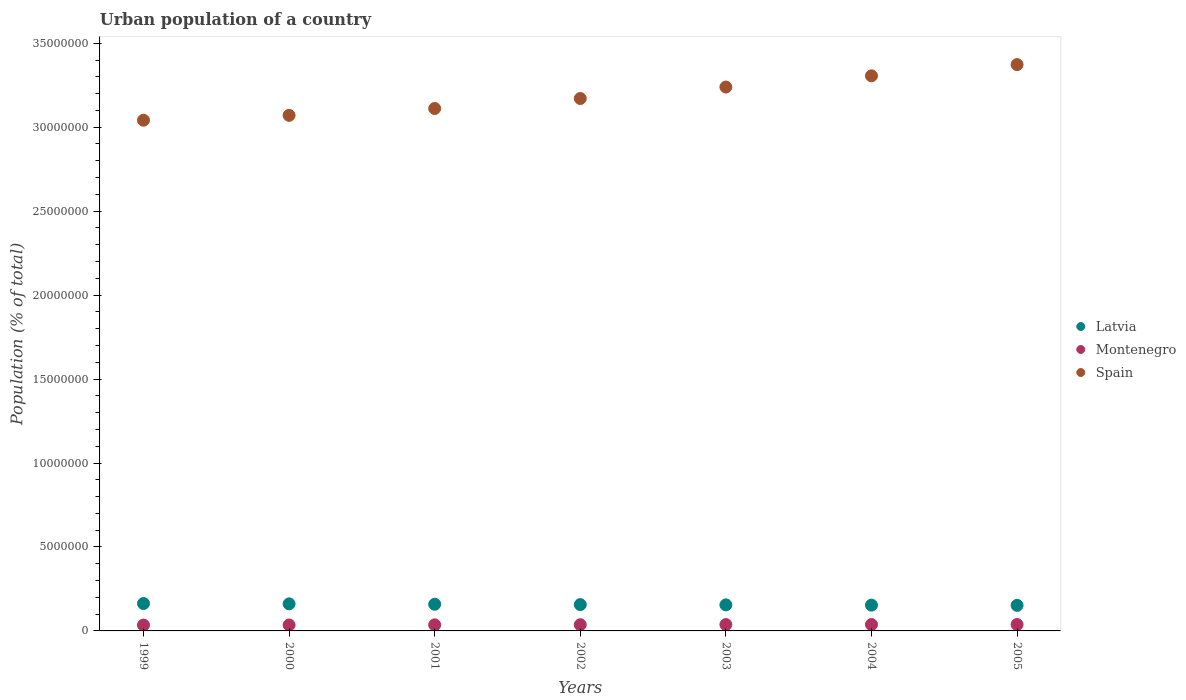How many different coloured dotlines are there?
Your answer should be very brief. 3. Is the number of dotlines equal to the number of legend labels?
Your answer should be compact. Yes. What is the urban population in Montenegro in 2002?
Offer a very short reply. 3.69e+05. Across all years, what is the maximum urban population in Latvia?
Ensure brevity in your answer.  1.63e+06. Across all years, what is the minimum urban population in Spain?
Ensure brevity in your answer.  3.04e+07. In which year was the urban population in Montenegro minimum?
Your answer should be compact. 1999. What is the total urban population in Montenegro in the graph?
Your answer should be compact. 2.57e+06. What is the difference between the urban population in Latvia in 2001 and that in 2003?
Offer a terse response. 3.69e+04. What is the difference between the urban population in Montenegro in 2004 and the urban population in Latvia in 2000?
Keep it short and to the point. -1.23e+06. What is the average urban population in Spain per year?
Provide a short and direct response. 3.19e+07. In the year 2002, what is the difference between the urban population in Latvia and urban population in Spain?
Provide a succinct answer. -3.01e+07. What is the ratio of the urban population in Montenegro in 2000 to that in 2003?
Keep it short and to the point. 0.94. Is the urban population in Montenegro in 1999 less than that in 2004?
Provide a succinct answer. Yes. What is the difference between the highest and the second highest urban population in Latvia?
Your answer should be compact. 1.93e+04. What is the difference between the highest and the lowest urban population in Montenegro?
Offer a terse response. 3.40e+04. Is the sum of the urban population in Latvia in 2002 and 2005 greater than the maximum urban population in Montenegro across all years?
Provide a short and direct response. Yes. Is it the case that in every year, the sum of the urban population in Montenegro and urban population in Spain  is greater than the urban population in Latvia?
Make the answer very short. Yes. How many years are there in the graph?
Give a very brief answer. 7. Are the values on the major ticks of Y-axis written in scientific E-notation?
Your answer should be compact. No. Does the graph contain grids?
Provide a short and direct response. No. Where does the legend appear in the graph?
Your answer should be compact. Center right. How many legend labels are there?
Keep it short and to the point. 3. How are the legend labels stacked?
Offer a very short reply. Vertical. What is the title of the graph?
Offer a terse response. Urban population of a country. Does "Curacao" appear as one of the legend labels in the graph?
Ensure brevity in your answer.  No. What is the label or title of the Y-axis?
Ensure brevity in your answer.  Population (% of total). What is the Population (% of total) in Latvia in 1999?
Offer a very short reply. 1.63e+06. What is the Population (% of total) of Montenegro in 1999?
Keep it short and to the point. 3.48e+05. What is the Population (% of total) in Spain in 1999?
Offer a terse response. 3.04e+07. What is the Population (% of total) of Latvia in 2000?
Keep it short and to the point. 1.61e+06. What is the Population (% of total) in Montenegro in 2000?
Give a very brief answer. 3.54e+05. What is the Population (% of total) in Spain in 2000?
Keep it short and to the point. 3.07e+07. What is the Population (% of total) of Latvia in 2001?
Your answer should be compact. 1.59e+06. What is the Population (% of total) in Montenegro in 2001?
Offer a very short reply. 3.62e+05. What is the Population (% of total) of Spain in 2001?
Ensure brevity in your answer.  3.11e+07. What is the Population (% of total) in Latvia in 2002?
Offer a very short reply. 1.57e+06. What is the Population (% of total) in Montenegro in 2002?
Your answer should be very brief. 3.69e+05. What is the Population (% of total) of Spain in 2002?
Keep it short and to the point. 3.17e+07. What is the Population (% of total) of Latvia in 2003?
Provide a succinct answer. 1.55e+06. What is the Population (% of total) in Montenegro in 2003?
Your answer should be very brief. 3.77e+05. What is the Population (% of total) of Spain in 2003?
Provide a short and direct response. 3.24e+07. What is the Population (% of total) in Latvia in 2004?
Provide a succinct answer. 1.54e+06. What is the Population (% of total) of Montenegro in 2004?
Your answer should be compact. 3.80e+05. What is the Population (% of total) in Spain in 2004?
Offer a terse response. 3.31e+07. What is the Population (% of total) of Latvia in 2005?
Keep it short and to the point. 1.52e+06. What is the Population (% of total) of Montenegro in 2005?
Ensure brevity in your answer.  3.82e+05. What is the Population (% of total) in Spain in 2005?
Keep it short and to the point. 3.37e+07. Across all years, what is the maximum Population (% of total) of Latvia?
Offer a very short reply. 1.63e+06. Across all years, what is the maximum Population (% of total) in Montenegro?
Ensure brevity in your answer.  3.82e+05. Across all years, what is the maximum Population (% of total) in Spain?
Offer a very short reply. 3.37e+07. Across all years, what is the minimum Population (% of total) in Latvia?
Ensure brevity in your answer.  1.52e+06. Across all years, what is the minimum Population (% of total) in Montenegro?
Your response must be concise. 3.48e+05. Across all years, what is the minimum Population (% of total) of Spain?
Give a very brief answer. 3.04e+07. What is the total Population (% of total) in Latvia in the graph?
Give a very brief answer. 1.10e+07. What is the total Population (% of total) of Montenegro in the graph?
Give a very brief answer. 2.57e+06. What is the total Population (% of total) of Spain in the graph?
Ensure brevity in your answer.  2.23e+08. What is the difference between the Population (% of total) in Latvia in 1999 and that in 2000?
Your answer should be compact. 1.93e+04. What is the difference between the Population (% of total) in Montenegro in 1999 and that in 2000?
Your response must be concise. -6110. What is the difference between the Population (% of total) in Spain in 1999 and that in 2000?
Provide a short and direct response. -2.89e+05. What is the difference between the Population (% of total) of Latvia in 1999 and that in 2001?
Your answer should be compact. 4.27e+04. What is the difference between the Population (% of total) of Montenegro in 1999 and that in 2001?
Your response must be concise. -1.37e+04. What is the difference between the Population (% of total) in Spain in 1999 and that in 2001?
Give a very brief answer. -6.98e+05. What is the difference between the Population (% of total) in Latvia in 1999 and that in 2002?
Provide a short and direct response. 6.33e+04. What is the difference between the Population (% of total) of Montenegro in 1999 and that in 2002?
Keep it short and to the point. -2.13e+04. What is the difference between the Population (% of total) of Spain in 1999 and that in 2002?
Offer a very short reply. -1.29e+06. What is the difference between the Population (% of total) in Latvia in 1999 and that in 2003?
Offer a very short reply. 7.96e+04. What is the difference between the Population (% of total) of Montenegro in 1999 and that in 2003?
Your answer should be compact. -2.89e+04. What is the difference between the Population (% of total) in Spain in 1999 and that in 2003?
Offer a terse response. -1.97e+06. What is the difference between the Population (% of total) of Latvia in 1999 and that in 2004?
Provide a succinct answer. 9.41e+04. What is the difference between the Population (% of total) of Montenegro in 1999 and that in 2004?
Give a very brief answer. -3.24e+04. What is the difference between the Population (% of total) in Spain in 1999 and that in 2004?
Provide a succinct answer. -2.64e+06. What is the difference between the Population (% of total) in Latvia in 1999 and that in 2005?
Keep it short and to the point. 1.08e+05. What is the difference between the Population (% of total) of Montenegro in 1999 and that in 2005?
Ensure brevity in your answer.  -3.40e+04. What is the difference between the Population (% of total) in Spain in 1999 and that in 2005?
Your response must be concise. -3.31e+06. What is the difference between the Population (% of total) in Latvia in 2000 and that in 2001?
Offer a terse response. 2.34e+04. What is the difference between the Population (% of total) in Montenegro in 2000 and that in 2001?
Make the answer very short. -7593. What is the difference between the Population (% of total) in Spain in 2000 and that in 2001?
Ensure brevity in your answer.  -4.09e+05. What is the difference between the Population (% of total) in Latvia in 2000 and that in 2002?
Provide a short and direct response. 4.41e+04. What is the difference between the Population (% of total) in Montenegro in 2000 and that in 2002?
Offer a terse response. -1.52e+04. What is the difference between the Population (% of total) in Spain in 2000 and that in 2002?
Offer a terse response. -1.00e+06. What is the difference between the Population (% of total) in Latvia in 2000 and that in 2003?
Offer a terse response. 6.03e+04. What is the difference between the Population (% of total) in Montenegro in 2000 and that in 2003?
Your answer should be very brief. -2.28e+04. What is the difference between the Population (% of total) of Spain in 2000 and that in 2003?
Ensure brevity in your answer.  -1.69e+06. What is the difference between the Population (% of total) of Latvia in 2000 and that in 2004?
Offer a very short reply. 7.49e+04. What is the difference between the Population (% of total) in Montenegro in 2000 and that in 2004?
Provide a short and direct response. -2.62e+04. What is the difference between the Population (% of total) of Spain in 2000 and that in 2004?
Keep it short and to the point. -2.35e+06. What is the difference between the Population (% of total) in Latvia in 2000 and that in 2005?
Provide a succinct answer. 8.91e+04. What is the difference between the Population (% of total) of Montenegro in 2000 and that in 2005?
Provide a short and direct response. -2.79e+04. What is the difference between the Population (% of total) of Spain in 2000 and that in 2005?
Your response must be concise. -3.02e+06. What is the difference between the Population (% of total) of Latvia in 2001 and that in 2002?
Your response must be concise. 2.07e+04. What is the difference between the Population (% of total) of Montenegro in 2001 and that in 2002?
Your answer should be very brief. -7606. What is the difference between the Population (% of total) of Spain in 2001 and that in 2002?
Offer a very short reply. -5.94e+05. What is the difference between the Population (% of total) of Latvia in 2001 and that in 2003?
Make the answer very short. 3.69e+04. What is the difference between the Population (% of total) in Montenegro in 2001 and that in 2003?
Keep it short and to the point. -1.52e+04. What is the difference between the Population (% of total) in Spain in 2001 and that in 2003?
Your answer should be very brief. -1.28e+06. What is the difference between the Population (% of total) in Latvia in 2001 and that in 2004?
Give a very brief answer. 5.14e+04. What is the difference between the Population (% of total) in Montenegro in 2001 and that in 2004?
Provide a succinct answer. -1.86e+04. What is the difference between the Population (% of total) in Spain in 2001 and that in 2004?
Keep it short and to the point. -1.94e+06. What is the difference between the Population (% of total) in Latvia in 2001 and that in 2005?
Give a very brief answer. 6.57e+04. What is the difference between the Population (% of total) of Montenegro in 2001 and that in 2005?
Offer a very short reply. -2.03e+04. What is the difference between the Population (% of total) in Spain in 2001 and that in 2005?
Offer a terse response. -2.61e+06. What is the difference between the Population (% of total) in Latvia in 2002 and that in 2003?
Offer a terse response. 1.62e+04. What is the difference between the Population (% of total) of Montenegro in 2002 and that in 2003?
Your answer should be compact. -7600. What is the difference between the Population (% of total) in Spain in 2002 and that in 2003?
Your response must be concise. -6.82e+05. What is the difference between the Population (% of total) in Latvia in 2002 and that in 2004?
Your answer should be very brief. 3.08e+04. What is the difference between the Population (% of total) of Montenegro in 2002 and that in 2004?
Your answer should be compact. -1.10e+04. What is the difference between the Population (% of total) in Spain in 2002 and that in 2004?
Keep it short and to the point. -1.35e+06. What is the difference between the Population (% of total) of Latvia in 2002 and that in 2005?
Ensure brevity in your answer.  4.51e+04. What is the difference between the Population (% of total) of Montenegro in 2002 and that in 2005?
Provide a short and direct response. -1.27e+04. What is the difference between the Population (% of total) of Spain in 2002 and that in 2005?
Keep it short and to the point. -2.02e+06. What is the difference between the Population (% of total) in Latvia in 2003 and that in 2004?
Offer a terse response. 1.46e+04. What is the difference between the Population (% of total) of Montenegro in 2003 and that in 2004?
Your answer should be very brief. -3441. What is the difference between the Population (% of total) of Spain in 2003 and that in 2004?
Your answer should be very brief. -6.68e+05. What is the difference between the Population (% of total) of Latvia in 2003 and that in 2005?
Provide a succinct answer. 2.88e+04. What is the difference between the Population (% of total) of Montenegro in 2003 and that in 2005?
Your response must be concise. -5109. What is the difference between the Population (% of total) of Spain in 2003 and that in 2005?
Your answer should be compact. -1.34e+06. What is the difference between the Population (% of total) of Latvia in 2004 and that in 2005?
Your answer should be compact. 1.43e+04. What is the difference between the Population (% of total) in Montenegro in 2004 and that in 2005?
Your response must be concise. -1668. What is the difference between the Population (% of total) in Spain in 2004 and that in 2005?
Offer a terse response. -6.68e+05. What is the difference between the Population (% of total) in Latvia in 1999 and the Population (% of total) in Montenegro in 2000?
Your response must be concise. 1.28e+06. What is the difference between the Population (% of total) in Latvia in 1999 and the Population (% of total) in Spain in 2000?
Offer a very short reply. -2.91e+07. What is the difference between the Population (% of total) of Montenegro in 1999 and the Population (% of total) of Spain in 2000?
Keep it short and to the point. -3.04e+07. What is the difference between the Population (% of total) in Latvia in 1999 and the Population (% of total) in Montenegro in 2001?
Offer a terse response. 1.27e+06. What is the difference between the Population (% of total) in Latvia in 1999 and the Population (% of total) in Spain in 2001?
Your answer should be very brief. -2.95e+07. What is the difference between the Population (% of total) in Montenegro in 1999 and the Population (% of total) in Spain in 2001?
Offer a very short reply. -3.08e+07. What is the difference between the Population (% of total) in Latvia in 1999 and the Population (% of total) in Montenegro in 2002?
Offer a terse response. 1.26e+06. What is the difference between the Population (% of total) in Latvia in 1999 and the Population (% of total) in Spain in 2002?
Make the answer very short. -3.01e+07. What is the difference between the Population (% of total) in Montenegro in 1999 and the Population (% of total) in Spain in 2002?
Offer a terse response. -3.14e+07. What is the difference between the Population (% of total) in Latvia in 1999 and the Population (% of total) in Montenegro in 2003?
Provide a succinct answer. 1.25e+06. What is the difference between the Population (% of total) of Latvia in 1999 and the Population (% of total) of Spain in 2003?
Ensure brevity in your answer.  -3.08e+07. What is the difference between the Population (% of total) in Montenegro in 1999 and the Population (% of total) in Spain in 2003?
Your answer should be compact. -3.20e+07. What is the difference between the Population (% of total) in Latvia in 1999 and the Population (% of total) in Montenegro in 2004?
Your answer should be very brief. 1.25e+06. What is the difference between the Population (% of total) in Latvia in 1999 and the Population (% of total) in Spain in 2004?
Your answer should be very brief. -3.14e+07. What is the difference between the Population (% of total) in Montenegro in 1999 and the Population (% of total) in Spain in 2004?
Keep it short and to the point. -3.27e+07. What is the difference between the Population (% of total) in Latvia in 1999 and the Population (% of total) in Montenegro in 2005?
Give a very brief answer. 1.25e+06. What is the difference between the Population (% of total) of Latvia in 1999 and the Population (% of total) of Spain in 2005?
Provide a succinct answer. -3.21e+07. What is the difference between the Population (% of total) in Montenegro in 1999 and the Population (% of total) in Spain in 2005?
Your response must be concise. -3.34e+07. What is the difference between the Population (% of total) in Latvia in 2000 and the Population (% of total) in Montenegro in 2001?
Your answer should be compact. 1.25e+06. What is the difference between the Population (% of total) in Latvia in 2000 and the Population (% of total) in Spain in 2001?
Give a very brief answer. -2.95e+07. What is the difference between the Population (% of total) in Montenegro in 2000 and the Population (% of total) in Spain in 2001?
Your answer should be compact. -3.08e+07. What is the difference between the Population (% of total) in Latvia in 2000 and the Population (% of total) in Montenegro in 2002?
Offer a very short reply. 1.24e+06. What is the difference between the Population (% of total) in Latvia in 2000 and the Population (% of total) in Spain in 2002?
Make the answer very short. -3.01e+07. What is the difference between the Population (% of total) of Montenegro in 2000 and the Population (% of total) of Spain in 2002?
Your answer should be compact. -3.14e+07. What is the difference between the Population (% of total) of Latvia in 2000 and the Population (% of total) of Montenegro in 2003?
Offer a terse response. 1.23e+06. What is the difference between the Population (% of total) of Latvia in 2000 and the Population (% of total) of Spain in 2003?
Provide a short and direct response. -3.08e+07. What is the difference between the Population (% of total) in Montenegro in 2000 and the Population (% of total) in Spain in 2003?
Your answer should be very brief. -3.20e+07. What is the difference between the Population (% of total) of Latvia in 2000 and the Population (% of total) of Montenegro in 2004?
Keep it short and to the point. 1.23e+06. What is the difference between the Population (% of total) of Latvia in 2000 and the Population (% of total) of Spain in 2004?
Provide a short and direct response. -3.14e+07. What is the difference between the Population (% of total) of Montenegro in 2000 and the Population (% of total) of Spain in 2004?
Your answer should be very brief. -3.27e+07. What is the difference between the Population (% of total) in Latvia in 2000 and the Population (% of total) in Montenegro in 2005?
Your answer should be very brief. 1.23e+06. What is the difference between the Population (% of total) of Latvia in 2000 and the Population (% of total) of Spain in 2005?
Provide a short and direct response. -3.21e+07. What is the difference between the Population (% of total) of Montenegro in 2000 and the Population (% of total) of Spain in 2005?
Offer a very short reply. -3.34e+07. What is the difference between the Population (% of total) of Latvia in 2001 and the Population (% of total) of Montenegro in 2002?
Your answer should be very brief. 1.22e+06. What is the difference between the Population (% of total) of Latvia in 2001 and the Population (% of total) of Spain in 2002?
Ensure brevity in your answer.  -3.01e+07. What is the difference between the Population (% of total) of Montenegro in 2001 and the Population (% of total) of Spain in 2002?
Ensure brevity in your answer.  -3.13e+07. What is the difference between the Population (% of total) of Latvia in 2001 and the Population (% of total) of Montenegro in 2003?
Provide a succinct answer. 1.21e+06. What is the difference between the Population (% of total) of Latvia in 2001 and the Population (% of total) of Spain in 2003?
Keep it short and to the point. -3.08e+07. What is the difference between the Population (% of total) of Montenegro in 2001 and the Population (% of total) of Spain in 2003?
Provide a short and direct response. -3.20e+07. What is the difference between the Population (% of total) of Latvia in 2001 and the Population (% of total) of Montenegro in 2004?
Your response must be concise. 1.21e+06. What is the difference between the Population (% of total) in Latvia in 2001 and the Population (% of total) in Spain in 2004?
Keep it short and to the point. -3.15e+07. What is the difference between the Population (% of total) in Montenegro in 2001 and the Population (% of total) in Spain in 2004?
Give a very brief answer. -3.27e+07. What is the difference between the Population (% of total) in Latvia in 2001 and the Population (% of total) in Montenegro in 2005?
Your answer should be very brief. 1.21e+06. What is the difference between the Population (% of total) in Latvia in 2001 and the Population (% of total) in Spain in 2005?
Offer a terse response. -3.21e+07. What is the difference between the Population (% of total) of Montenegro in 2001 and the Population (% of total) of Spain in 2005?
Keep it short and to the point. -3.34e+07. What is the difference between the Population (% of total) of Latvia in 2002 and the Population (% of total) of Montenegro in 2003?
Offer a very short reply. 1.19e+06. What is the difference between the Population (% of total) of Latvia in 2002 and the Population (% of total) of Spain in 2003?
Your answer should be compact. -3.08e+07. What is the difference between the Population (% of total) in Montenegro in 2002 and the Population (% of total) in Spain in 2003?
Offer a very short reply. -3.20e+07. What is the difference between the Population (% of total) in Latvia in 2002 and the Population (% of total) in Montenegro in 2004?
Your answer should be very brief. 1.19e+06. What is the difference between the Population (% of total) in Latvia in 2002 and the Population (% of total) in Spain in 2004?
Ensure brevity in your answer.  -3.15e+07. What is the difference between the Population (% of total) of Montenegro in 2002 and the Population (% of total) of Spain in 2004?
Keep it short and to the point. -3.27e+07. What is the difference between the Population (% of total) of Latvia in 2002 and the Population (% of total) of Montenegro in 2005?
Keep it short and to the point. 1.19e+06. What is the difference between the Population (% of total) of Latvia in 2002 and the Population (% of total) of Spain in 2005?
Make the answer very short. -3.22e+07. What is the difference between the Population (% of total) in Montenegro in 2002 and the Population (% of total) in Spain in 2005?
Provide a short and direct response. -3.34e+07. What is the difference between the Population (% of total) of Latvia in 2003 and the Population (% of total) of Montenegro in 2004?
Provide a short and direct response. 1.17e+06. What is the difference between the Population (% of total) of Latvia in 2003 and the Population (% of total) of Spain in 2004?
Offer a very short reply. -3.15e+07. What is the difference between the Population (% of total) of Montenegro in 2003 and the Population (% of total) of Spain in 2004?
Keep it short and to the point. -3.27e+07. What is the difference between the Population (% of total) in Latvia in 2003 and the Population (% of total) in Montenegro in 2005?
Your response must be concise. 1.17e+06. What is the difference between the Population (% of total) in Latvia in 2003 and the Population (% of total) in Spain in 2005?
Your answer should be very brief. -3.22e+07. What is the difference between the Population (% of total) of Montenegro in 2003 and the Population (% of total) of Spain in 2005?
Ensure brevity in your answer.  -3.34e+07. What is the difference between the Population (% of total) in Latvia in 2004 and the Population (% of total) in Montenegro in 2005?
Ensure brevity in your answer.  1.15e+06. What is the difference between the Population (% of total) of Latvia in 2004 and the Population (% of total) of Spain in 2005?
Offer a terse response. -3.22e+07. What is the difference between the Population (% of total) of Montenegro in 2004 and the Population (% of total) of Spain in 2005?
Provide a succinct answer. -3.33e+07. What is the average Population (% of total) in Latvia per year?
Give a very brief answer. 1.57e+06. What is the average Population (% of total) in Montenegro per year?
Provide a short and direct response. 3.68e+05. What is the average Population (% of total) in Spain per year?
Your answer should be compact. 3.19e+07. In the year 1999, what is the difference between the Population (% of total) in Latvia and Population (% of total) in Montenegro?
Offer a very short reply. 1.28e+06. In the year 1999, what is the difference between the Population (% of total) of Latvia and Population (% of total) of Spain?
Your response must be concise. -2.88e+07. In the year 1999, what is the difference between the Population (% of total) in Montenegro and Population (% of total) in Spain?
Offer a very short reply. -3.01e+07. In the year 2000, what is the difference between the Population (% of total) of Latvia and Population (% of total) of Montenegro?
Provide a succinct answer. 1.26e+06. In the year 2000, what is the difference between the Population (% of total) of Latvia and Population (% of total) of Spain?
Ensure brevity in your answer.  -2.91e+07. In the year 2000, what is the difference between the Population (% of total) of Montenegro and Population (% of total) of Spain?
Make the answer very short. -3.04e+07. In the year 2001, what is the difference between the Population (% of total) of Latvia and Population (% of total) of Montenegro?
Keep it short and to the point. 1.23e+06. In the year 2001, what is the difference between the Population (% of total) in Latvia and Population (% of total) in Spain?
Offer a terse response. -2.95e+07. In the year 2001, what is the difference between the Population (% of total) of Montenegro and Population (% of total) of Spain?
Offer a terse response. -3.08e+07. In the year 2002, what is the difference between the Population (% of total) in Latvia and Population (% of total) in Montenegro?
Your response must be concise. 1.20e+06. In the year 2002, what is the difference between the Population (% of total) in Latvia and Population (% of total) in Spain?
Keep it short and to the point. -3.01e+07. In the year 2002, what is the difference between the Population (% of total) of Montenegro and Population (% of total) of Spain?
Keep it short and to the point. -3.13e+07. In the year 2003, what is the difference between the Population (% of total) in Latvia and Population (% of total) in Montenegro?
Your response must be concise. 1.17e+06. In the year 2003, what is the difference between the Population (% of total) of Latvia and Population (% of total) of Spain?
Keep it short and to the point. -3.08e+07. In the year 2003, what is the difference between the Population (% of total) in Montenegro and Population (% of total) in Spain?
Your response must be concise. -3.20e+07. In the year 2004, what is the difference between the Population (% of total) in Latvia and Population (% of total) in Montenegro?
Keep it short and to the point. 1.16e+06. In the year 2004, what is the difference between the Population (% of total) of Latvia and Population (% of total) of Spain?
Provide a succinct answer. -3.15e+07. In the year 2004, what is the difference between the Population (% of total) in Montenegro and Population (% of total) in Spain?
Your answer should be compact. -3.27e+07. In the year 2005, what is the difference between the Population (% of total) in Latvia and Population (% of total) in Montenegro?
Offer a terse response. 1.14e+06. In the year 2005, what is the difference between the Population (% of total) in Latvia and Population (% of total) in Spain?
Give a very brief answer. -3.22e+07. In the year 2005, what is the difference between the Population (% of total) in Montenegro and Population (% of total) in Spain?
Make the answer very short. -3.33e+07. What is the ratio of the Population (% of total) of Montenegro in 1999 to that in 2000?
Provide a succinct answer. 0.98. What is the ratio of the Population (% of total) of Spain in 1999 to that in 2000?
Your response must be concise. 0.99. What is the ratio of the Population (% of total) of Latvia in 1999 to that in 2001?
Ensure brevity in your answer.  1.03. What is the ratio of the Population (% of total) of Montenegro in 1999 to that in 2001?
Your response must be concise. 0.96. What is the ratio of the Population (% of total) of Spain in 1999 to that in 2001?
Offer a terse response. 0.98. What is the ratio of the Population (% of total) in Latvia in 1999 to that in 2002?
Ensure brevity in your answer.  1.04. What is the ratio of the Population (% of total) of Montenegro in 1999 to that in 2002?
Provide a short and direct response. 0.94. What is the ratio of the Population (% of total) in Spain in 1999 to that in 2002?
Your answer should be very brief. 0.96. What is the ratio of the Population (% of total) of Latvia in 1999 to that in 2003?
Your answer should be compact. 1.05. What is the ratio of the Population (% of total) of Montenegro in 1999 to that in 2003?
Provide a succinct answer. 0.92. What is the ratio of the Population (% of total) in Spain in 1999 to that in 2003?
Ensure brevity in your answer.  0.94. What is the ratio of the Population (% of total) of Latvia in 1999 to that in 2004?
Offer a very short reply. 1.06. What is the ratio of the Population (% of total) of Montenegro in 1999 to that in 2004?
Make the answer very short. 0.92. What is the ratio of the Population (% of total) of Spain in 1999 to that in 2004?
Offer a very short reply. 0.92. What is the ratio of the Population (% of total) of Latvia in 1999 to that in 2005?
Make the answer very short. 1.07. What is the ratio of the Population (% of total) of Montenegro in 1999 to that in 2005?
Make the answer very short. 0.91. What is the ratio of the Population (% of total) of Spain in 1999 to that in 2005?
Offer a very short reply. 0.9. What is the ratio of the Population (% of total) in Latvia in 2000 to that in 2001?
Your answer should be compact. 1.01. What is the ratio of the Population (% of total) of Montenegro in 2000 to that in 2001?
Your response must be concise. 0.98. What is the ratio of the Population (% of total) of Spain in 2000 to that in 2001?
Offer a very short reply. 0.99. What is the ratio of the Population (% of total) in Latvia in 2000 to that in 2002?
Offer a very short reply. 1.03. What is the ratio of the Population (% of total) in Montenegro in 2000 to that in 2002?
Provide a succinct answer. 0.96. What is the ratio of the Population (% of total) of Spain in 2000 to that in 2002?
Give a very brief answer. 0.97. What is the ratio of the Population (% of total) in Latvia in 2000 to that in 2003?
Your response must be concise. 1.04. What is the ratio of the Population (% of total) in Montenegro in 2000 to that in 2003?
Keep it short and to the point. 0.94. What is the ratio of the Population (% of total) in Spain in 2000 to that in 2003?
Your answer should be compact. 0.95. What is the ratio of the Population (% of total) in Latvia in 2000 to that in 2004?
Offer a terse response. 1.05. What is the ratio of the Population (% of total) of Montenegro in 2000 to that in 2004?
Offer a terse response. 0.93. What is the ratio of the Population (% of total) in Spain in 2000 to that in 2004?
Offer a very short reply. 0.93. What is the ratio of the Population (% of total) of Latvia in 2000 to that in 2005?
Ensure brevity in your answer.  1.06. What is the ratio of the Population (% of total) in Montenegro in 2000 to that in 2005?
Provide a short and direct response. 0.93. What is the ratio of the Population (% of total) in Spain in 2000 to that in 2005?
Make the answer very short. 0.91. What is the ratio of the Population (% of total) of Latvia in 2001 to that in 2002?
Provide a short and direct response. 1.01. What is the ratio of the Population (% of total) in Montenegro in 2001 to that in 2002?
Offer a terse response. 0.98. What is the ratio of the Population (% of total) in Spain in 2001 to that in 2002?
Your response must be concise. 0.98. What is the ratio of the Population (% of total) of Latvia in 2001 to that in 2003?
Ensure brevity in your answer.  1.02. What is the ratio of the Population (% of total) in Montenegro in 2001 to that in 2003?
Offer a terse response. 0.96. What is the ratio of the Population (% of total) in Spain in 2001 to that in 2003?
Your answer should be compact. 0.96. What is the ratio of the Population (% of total) in Latvia in 2001 to that in 2004?
Give a very brief answer. 1.03. What is the ratio of the Population (% of total) of Montenegro in 2001 to that in 2004?
Offer a terse response. 0.95. What is the ratio of the Population (% of total) of Spain in 2001 to that in 2004?
Offer a terse response. 0.94. What is the ratio of the Population (% of total) of Latvia in 2001 to that in 2005?
Your response must be concise. 1.04. What is the ratio of the Population (% of total) in Montenegro in 2001 to that in 2005?
Provide a succinct answer. 0.95. What is the ratio of the Population (% of total) of Spain in 2001 to that in 2005?
Offer a terse response. 0.92. What is the ratio of the Population (% of total) in Latvia in 2002 to that in 2003?
Provide a short and direct response. 1.01. What is the ratio of the Population (% of total) of Montenegro in 2002 to that in 2003?
Ensure brevity in your answer.  0.98. What is the ratio of the Population (% of total) in Spain in 2002 to that in 2003?
Keep it short and to the point. 0.98. What is the ratio of the Population (% of total) in Latvia in 2002 to that in 2004?
Your response must be concise. 1.02. What is the ratio of the Population (% of total) in Montenegro in 2002 to that in 2004?
Your answer should be compact. 0.97. What is the ratio of the Population (% of total) of Spain in 2002 to that in 2004?
Your answer should be compact. 0.96. What is the ratio of the Population (% of total) of Latvia in 2002 to that in 2005?
Make the answer very short. 1.03. What is the ratio of the Population (% of total) in Montenegro in 2002 to that in 2005?
Ensure brevity in your answer.  0.97. What is the ratio of the Population (% of total) of Spain in 2002 to that in 2005?
Give a very brief answer. 0.94. What is the ratio of the Population (% of total) of Latvia in 2003 to that in 2004?
Provide a succinct answer. 1.01. What is the ratio of the Population (% of total) in Montenegro in 2003 to that in 2004?
Your answer should be very brief. 0.99. What is the ratio of the Population (% of total) in Spain in 2003 to that in 2004?
Provide a short and direct response. 0.98. What is the ratio of the Population (% of total) in Montenegro in 2003 to that in 2005?
Your answer should be very brief. 0.99. What is the ratio of the Population (% of total) in Spain in 2003 to that in 2005?
Keep it short and to the point. 0.96. What is the ratio of the Population (% of total) in Latvia in 2004 to that in 2005?
Your response must be concise. 1.01. What is the ratio of the Population (% of total) in Montenegro in 2004 to that in 2005?
Provide a short and direct response. 1. What is the ratio of the Population (% of total) in Spain in 2004 to that in 2005?
Offer a terse response. 0.98. What is the difference between the highest and the second highest Population (% of total) of Latvia?
Ensure brevity in your answer.  1.93e+04. What is the difference between the highest and the second highest Population (% of total) in Montenegro?
Ensure brevity in your answer.  1668. What is the difference between the highest and the second highest Population (% of total) of Spain?
Ensure brevity in your answer.  6.68e+05. What is the difference between the highest and the lowest Population (% of total) of Latvia?
Your answer should be very brief. 1.08e+05. What is the difference between the highest and the lowest Population (% of total) in Montenegro?
Ensure brevity in your answer.  3.40e+04. What is the difference between the highest and the lowest Population (% of total) in Spain?
Your answer should be compact. 3.31e+06. 